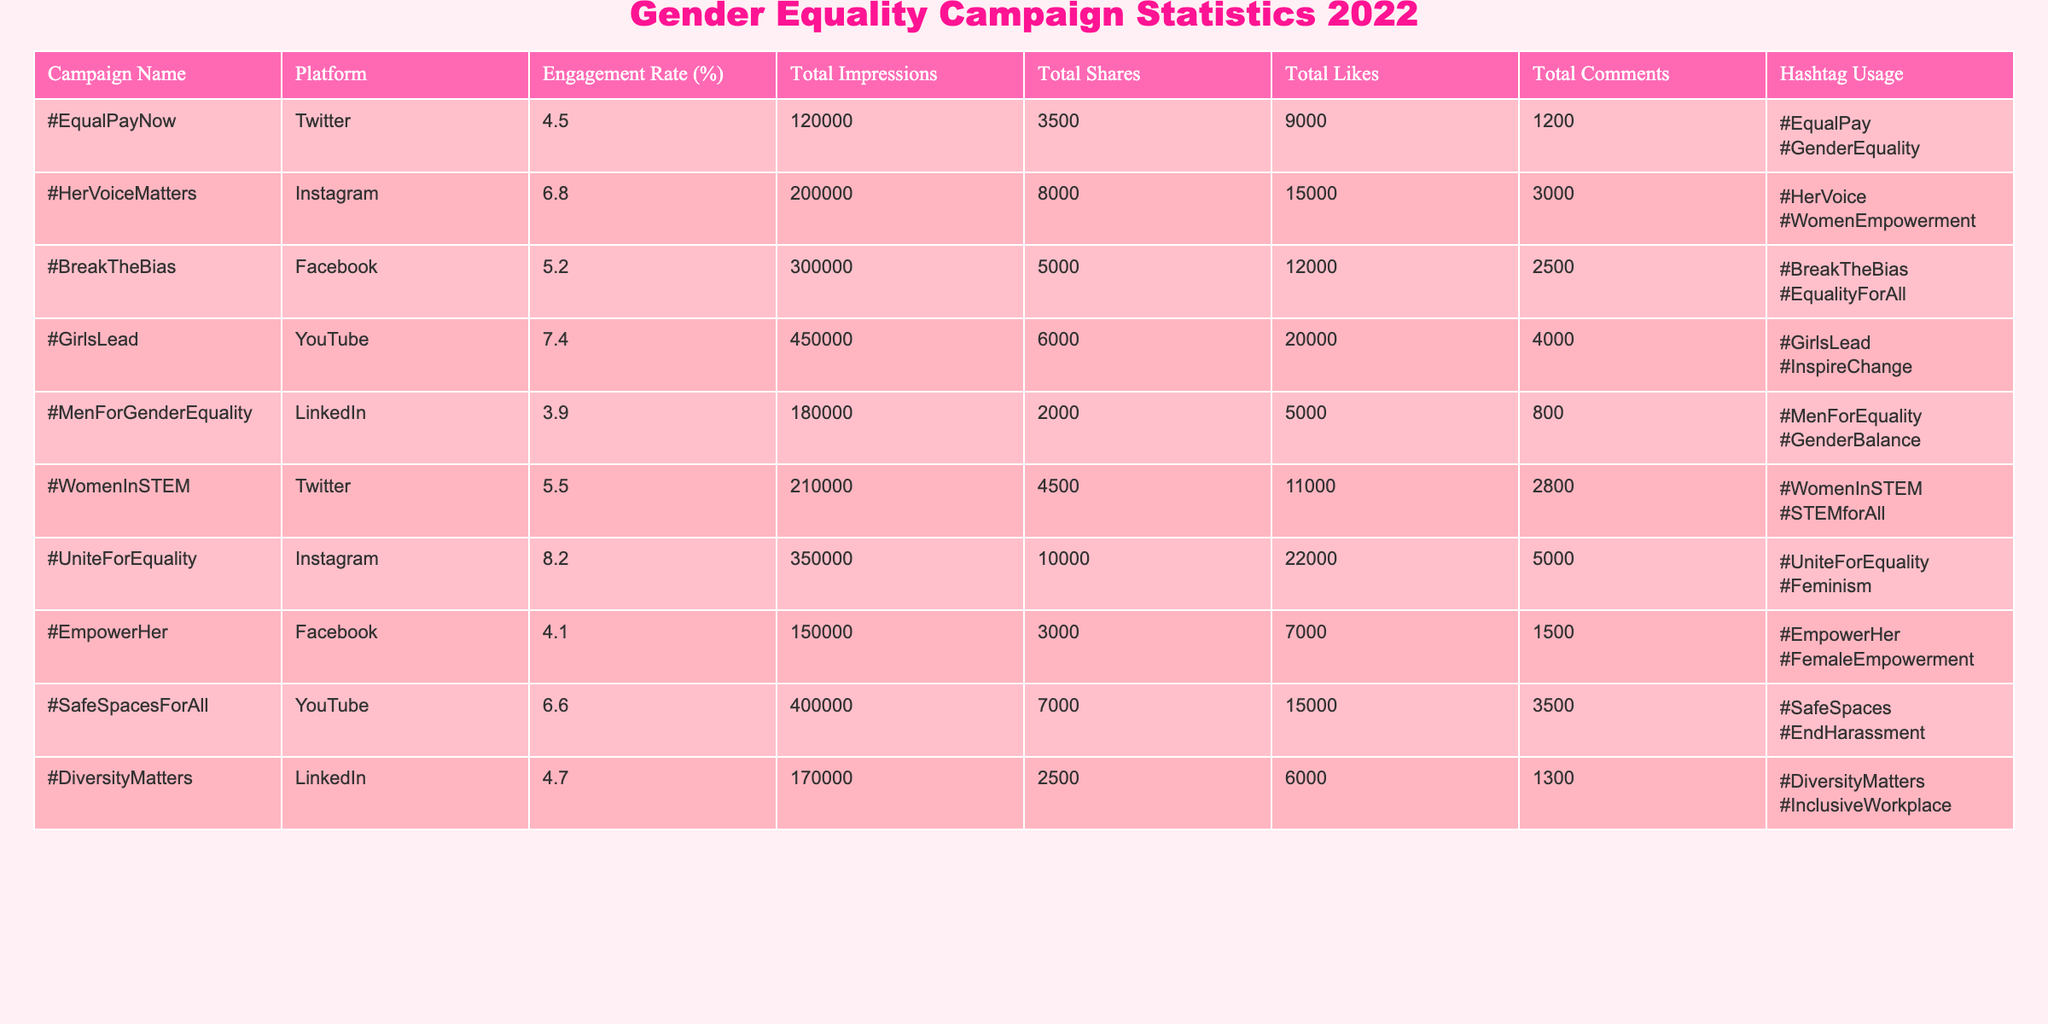What is the engagement rate of the #GirlsLead campaign? The engagement rate for the #GirlsLead campaign is listed in the "Engagement Rate (%)" column, which shows 7.4% as the corresponding value for its row.
Answer: 7.4% Which campaign had the highest total likes? By looking at the "Total Likes" column, we find that the #GirlsLead campaign has the highest total likes with a count of 20,000.
Answer: #GirlsLead What is the average engagement rate of campaigns on Twitter? The engagement rates for Twitter campaigns are #EqualPayNow (4.5%), #WomenInSTEM (5.5%), totaling 10%. There are 2 campaigns, so the average is 10% / 2 = 5%.
Answer: 5% Did the #UniteForEquality campaign receive more total shares than the #HerVoiceMatters campaign? The total shares for #UniteForEquality is 10,000, while #HerVoiceMatters has 8,000 shares. Since 10,000 > 8,000, the answer is yes.
Answer: Yes What is the total number of comments for all campaigns on Instagram? The total comments for Instagram campaigns are #HerVoiceMatters (3,000) and #UniteForEquality (5,000). Adding these gives us 3,000 + 5,000 = 8,000 total comments for Instagram.
Answer: 8,000 Which platform had the campaign with the lowest engagement rate, and what was the engagement rate? The campaign with the lowest engagement rate is #MenForGenderEquality on LinkedIn, which has an engagement rate of 3.9%.
Answer: LinkedIn, 3.9% What is the total number of impressions across all campaigns on Facebook? The Facebook campaigns are #BreakTheBias (300,000) and #EmpowerHer (150,000). Their total impressions are 300,000 + 150,000 = 450,000.
Answer: 450,000 Is the total share count for the #SafeSpacesForAll campaign greater than the total likes for the #EmpowerHer campaign? The #SafeSpacesForAll campaign has 7,000 shares, while #EmpowerHer has 7,000 likes. Since 7,000 is not greater than 7,000, the answer is no.
Answer: No 